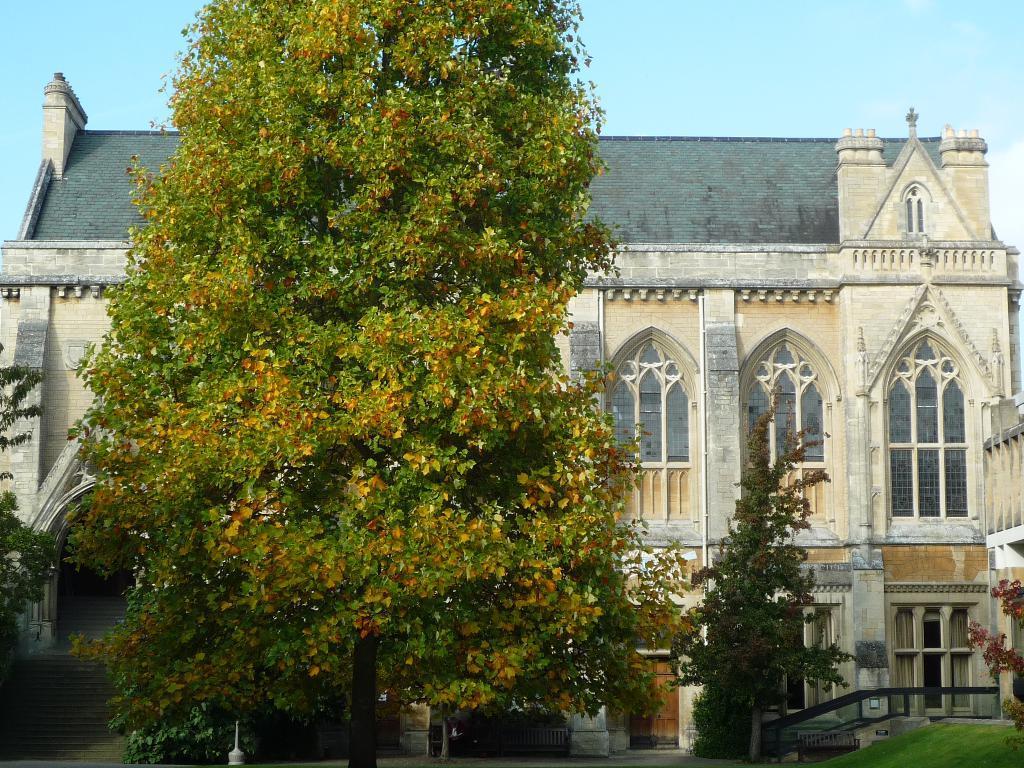Describe this image in one or two sentences. In this picture in the front there are trees and there's grass on the ground. In the center there is a railing and there is a building. 